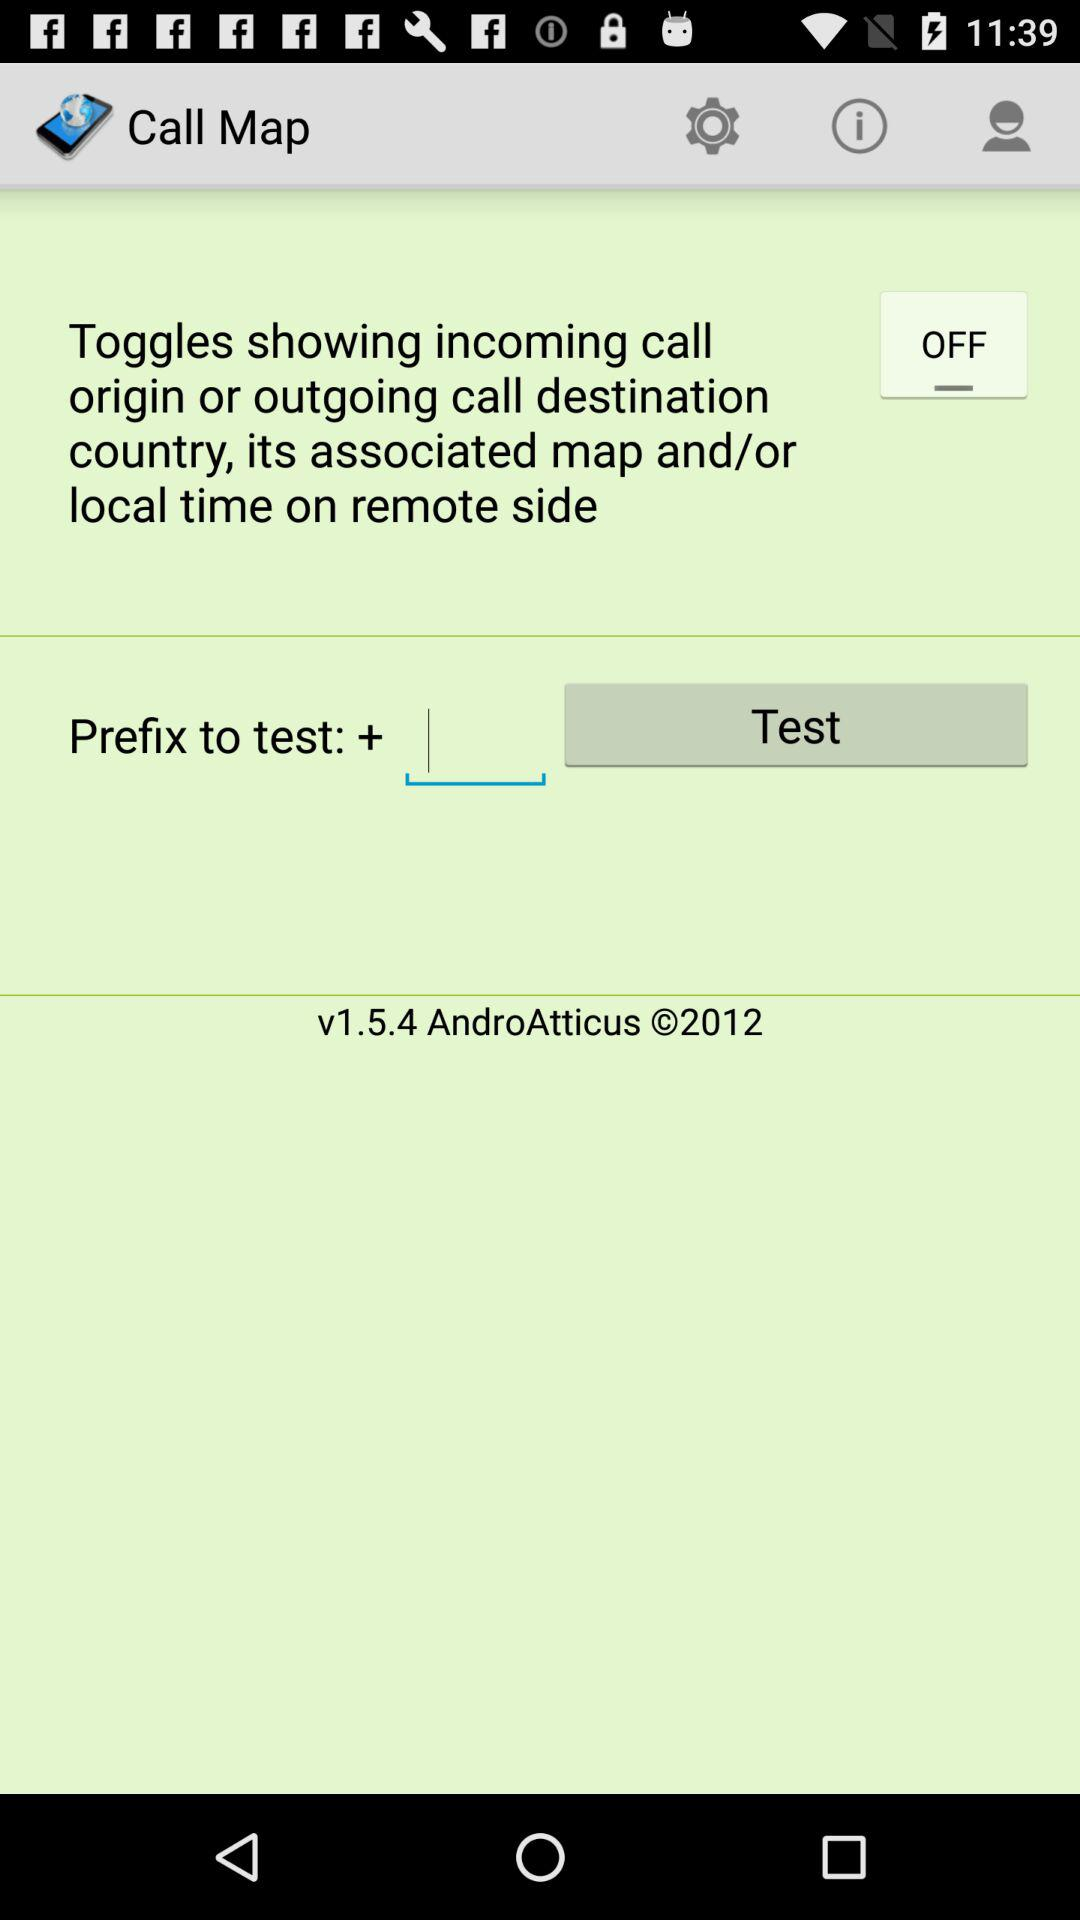What is the year of copyright for the application? The year of copyright is 2012. 